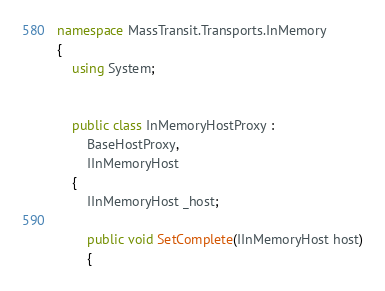Convert code to text. <code><loc_0><loc_0><loc_500><loc_500><_C#_>namespace MassTransit.Transports.InMemory
{
    using System;


    public class InMemoryHostProxy :
        BaseHostProxy,
        IInMemoryHost
    {
        IInMemoryHost _host;

        public void SetComplete(IInMemoryHost host)
        {</code> 